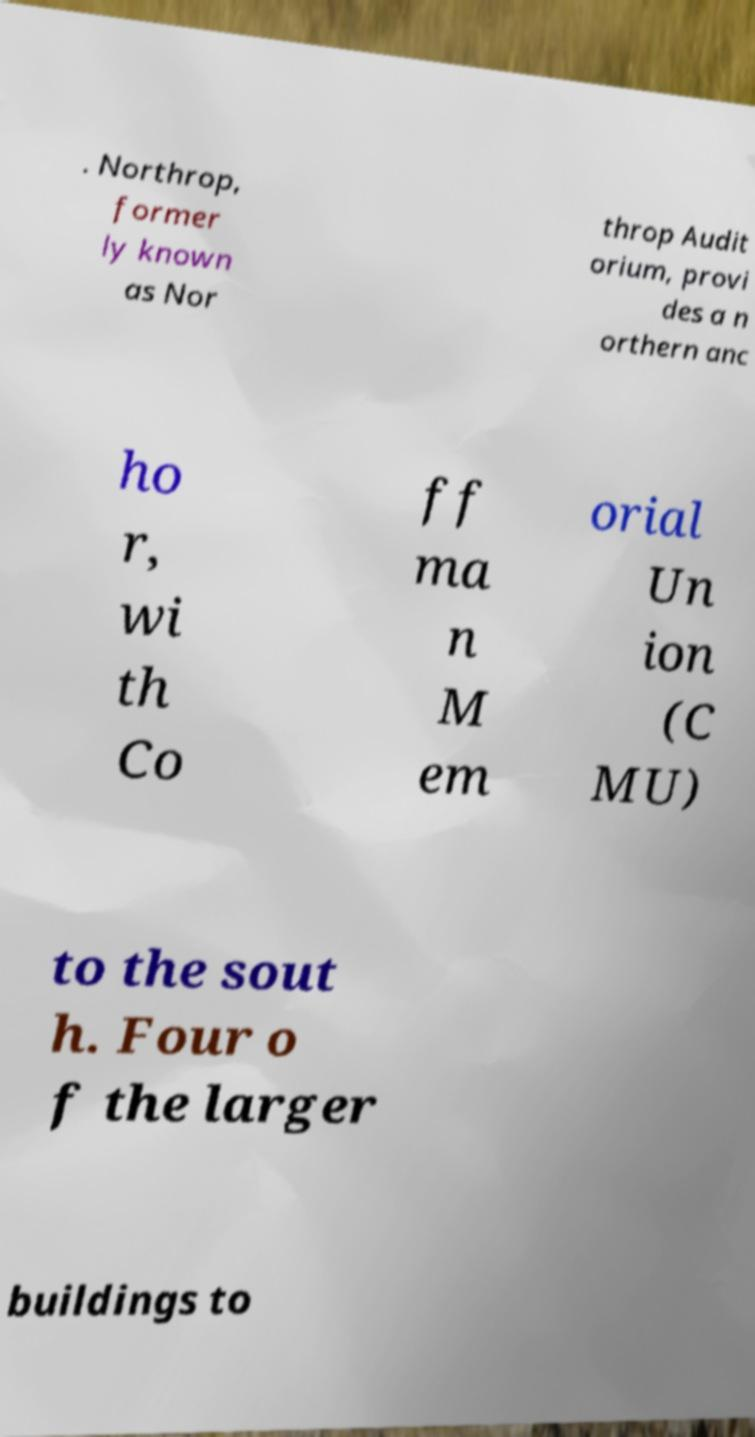Please identify and transcribe the text found in this image. . Northrop, former ly known as Nor throp Audit orium, provi des a n orthern anc ho r, wi th Co ff ma n M em orial Un ion (C MU) to the sout h. Four o f the larger buildings to 